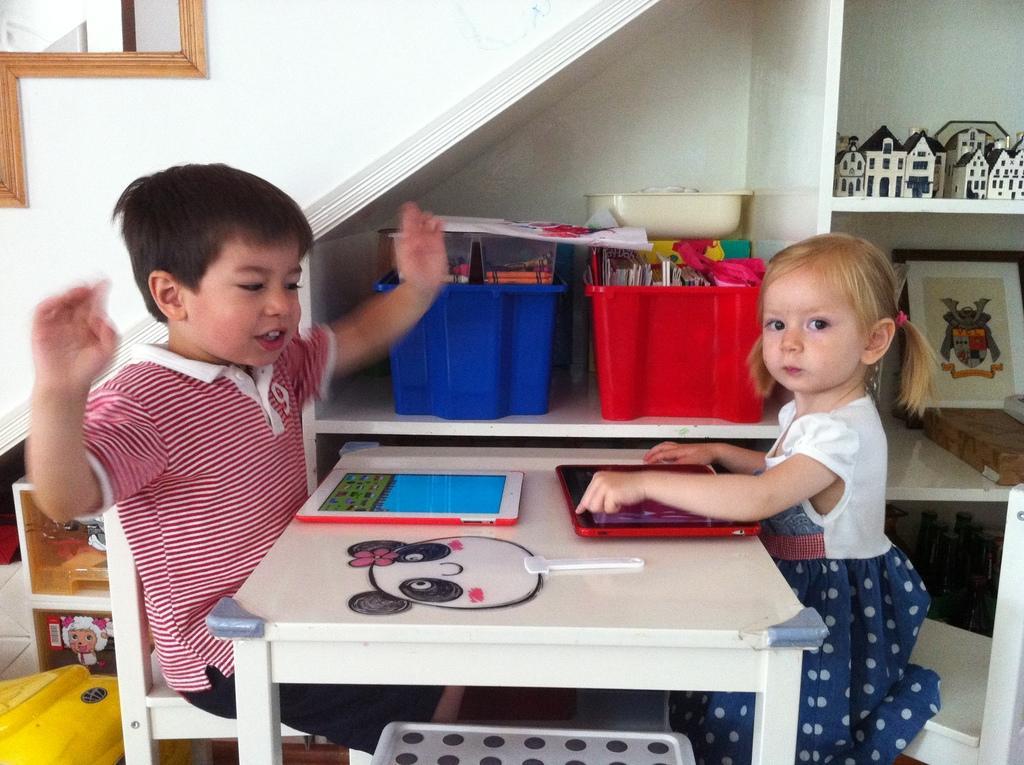In one or two sentences, can you explain what this image depicts? In this picture there is a boy and a girl who are having a table in front of them and their two smartphones in front of them 